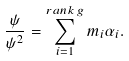Convert formula to latex. <formula><loc_0><loc_0><loc_500><loc_500>\frac { \psi } { { \psi } ^ { 2 } } = \sum _ { i = 1 } ^ { r a n k \, g } m _ { i } { \alpha } _ { i } .</formula> 